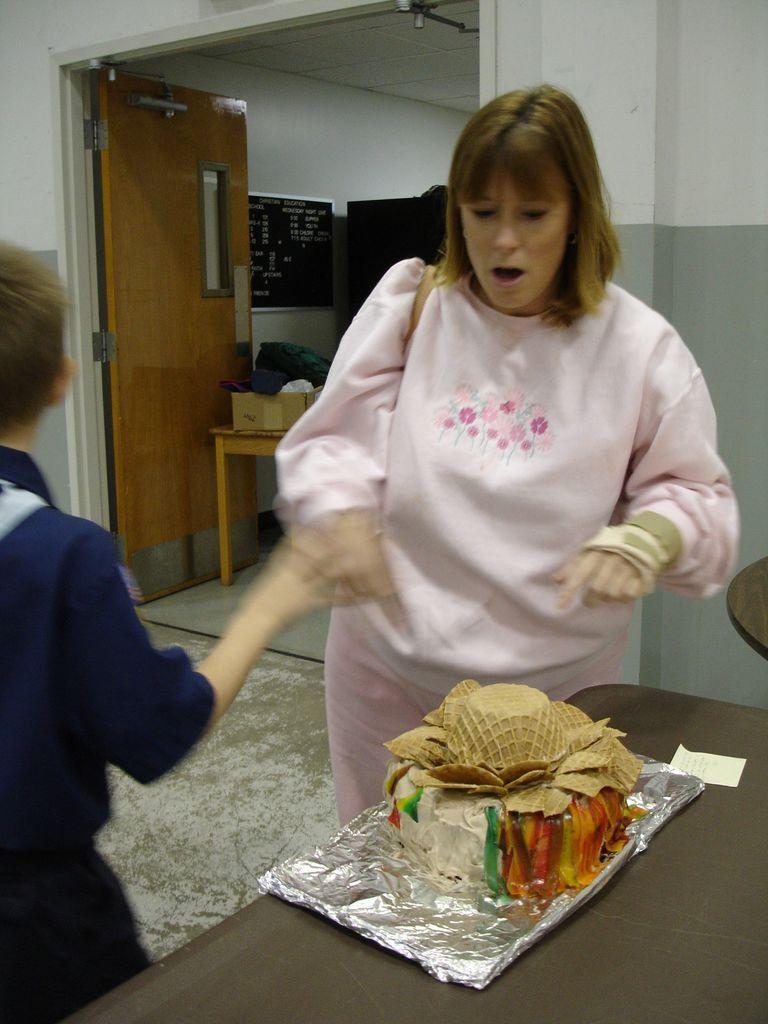Describe this image in one or two sentences. In this image there is a woman standing on the floor. Before her there is a table having a cake. Left side a person is standing. There is a table kept near the door. On the table there are few objects. A board is attached to the wall. Behind the woman there is an object. 